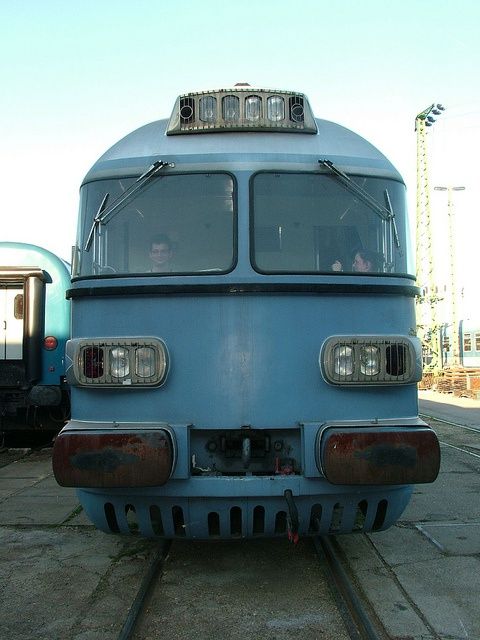Describe the objects in this image and their specific colors. I can see train in lightblue, black, blue, and teal tones, train in lightblue, black, ivory, turquoise, and blue tones, people in lightblue, gray, and teal tones, and people in lightblue, teal, and gray tones in this image. 